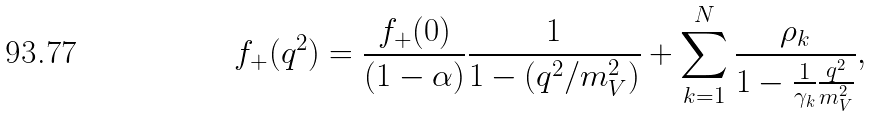Convert formula to latex. <formula><loc_0><loc_0><loc_500><loc_500>f _ { + } ( q ^ { 2 } ) = \frac { f _ { + } ( 0 ) } { ( 1 - \alpha ) } \frac { 1 } { 1 - ( q ^ { 2 } / m _ { V } ^ { 2 } ) } + \sum _ { k = 1 } ^ { N } \frac { \rho _ { k } } { 1 - \frac { 1 } { \gamma _ { k } } \frac { q ^ { 2 } } { m _ { V } ^ { 2 } } } ,</formula> 